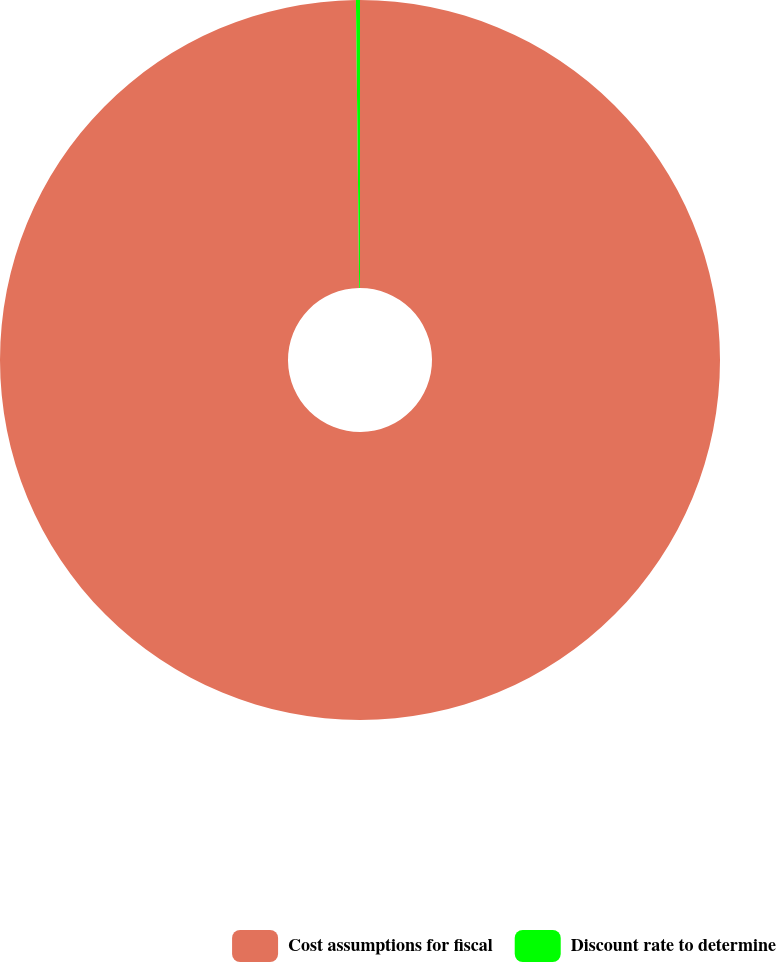Convert chart to OTSL. <chart><loc_0><loc_0><loc_500><loc_500><pie_chart><fcel>Cost assumptions for fiscal<fcel>Discount rate to determine<nl><fcel>99.82%<fcel>0.18%<nl></chart> 